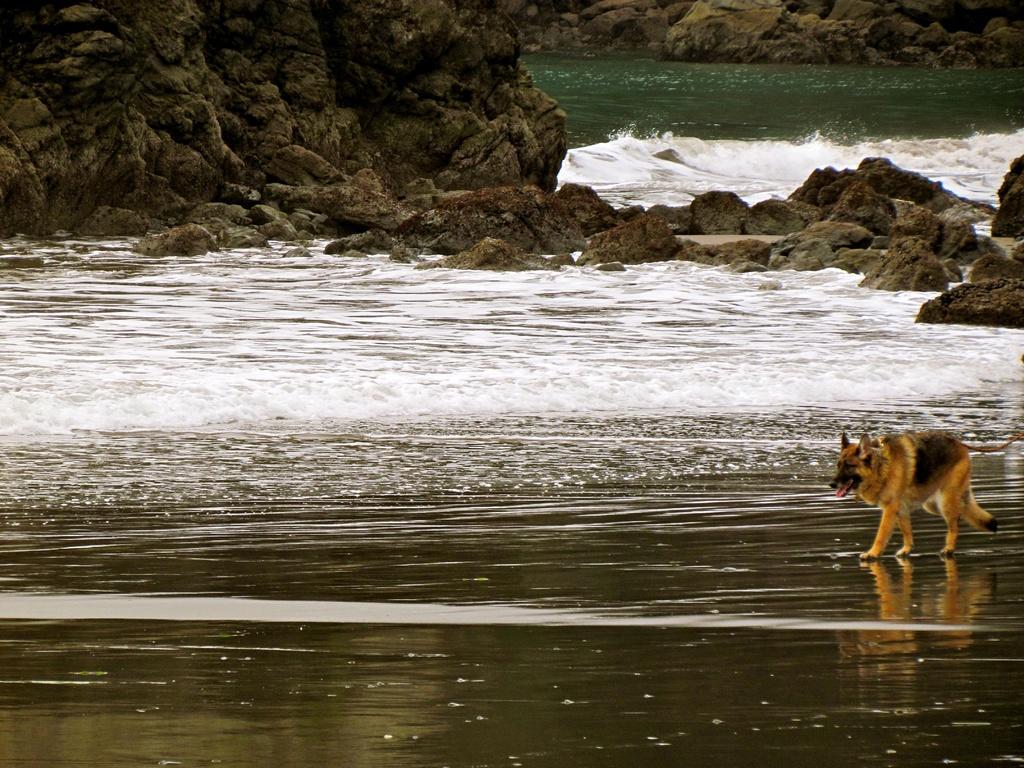Please provide a concise description of this image. We can see a fox walking and we can see water,rock and stones. 